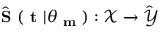<formula> <loc_0><loc_0><loc_500><loc_500>\hat { S } ( t | \theta _ { m } ) \colon \mathcal { X } \hat { \mathcal { Y } }</formula> 